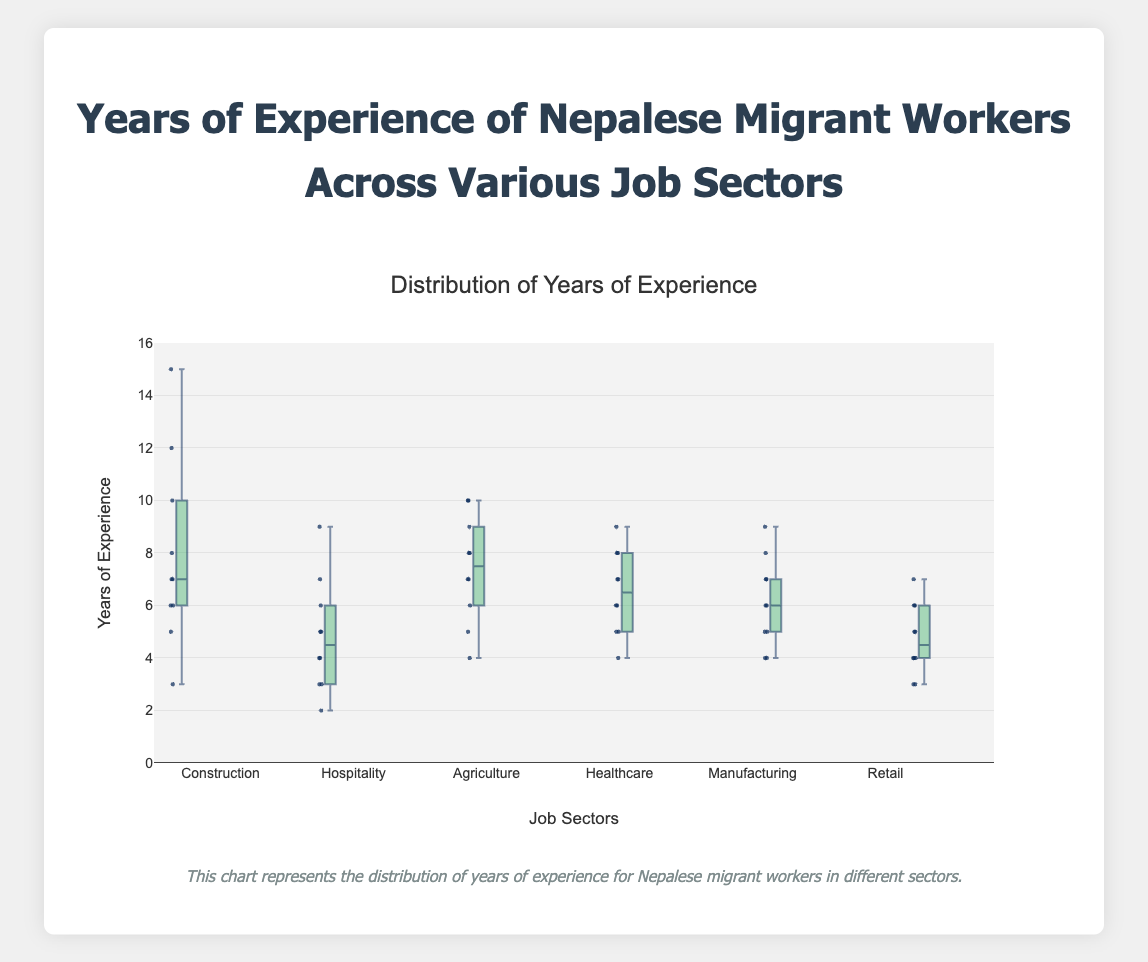What is the median years of experience for Nepalese migrant workers in the Healthcare sector? The median is located at the middle value when the data points are ordered. In the Healthcare sector, the ordered data points are [4, 5, 5, 6, 6, 7, 7, 8, 8, 9]. The median is the average of the 5th and 6th values, which are both 6.5.
Answer: 6.5 Which sector has the highest maximum years of experience? By looking at the highest points across all box plots, we can see that the Construction sector has the highest maximum value of 15 years.
Answer: Construction In which sector is the interquartile range (IQR) smallest? The IQR is the range between the first quartile (Q1) and the third quartile (Q3). By observing the box plots, the Retail sector has the smallest IQR as its box (between Q1 and Q3) is the narrowest.
Answer: Retail How many job sectors have a median years of experience above 6? By looking at the median lines (the lines inside each box), we can see that the sectors with a median value above 6 are Agriculture, Healthcare, and Manufacturing, which makes it 3 sectors.
Answer: 3 What is the approximate range of the years of experience in Agriculture? The range is calculated by subtracting the minimum from the maximum value. For Agriculture, the minimum is 4 and the maximum is 10, so the range is 10 - 4 = 6 years.
Answer: 6 Which sector shows the least variability in years of experience? Variability is indicated by the spread of the data points, which can be assessed by the length of the box and whiskers. The Retail sector has the least variability as both the box and whiskers are shortest.
Answer: Retail Do any sectors show potential outliers, and if so, which ones? Outliers in box plots are typically shown as points outside the whiskers. In this figure, Construction has a potential outlier at 15 years.
Answer: Construction What is the median years of experience in the Construction sector, and how does it compare to the median in Hospitality? The median in Construction is found in the middle of [3, 5, 6, 6, 7, 7, 8, 10, 12, 15], which is 7. The median in Hospitality is in the middle of [2, 3, 3, 4, 4, 5, 5, 6, 7, 9], which is 5. Thus, the median in Construction is 2 years higher than in Hospitality.
Answer: Construction has a median of 7; Hospitality has a median of 5; Construction is 2 years higher 